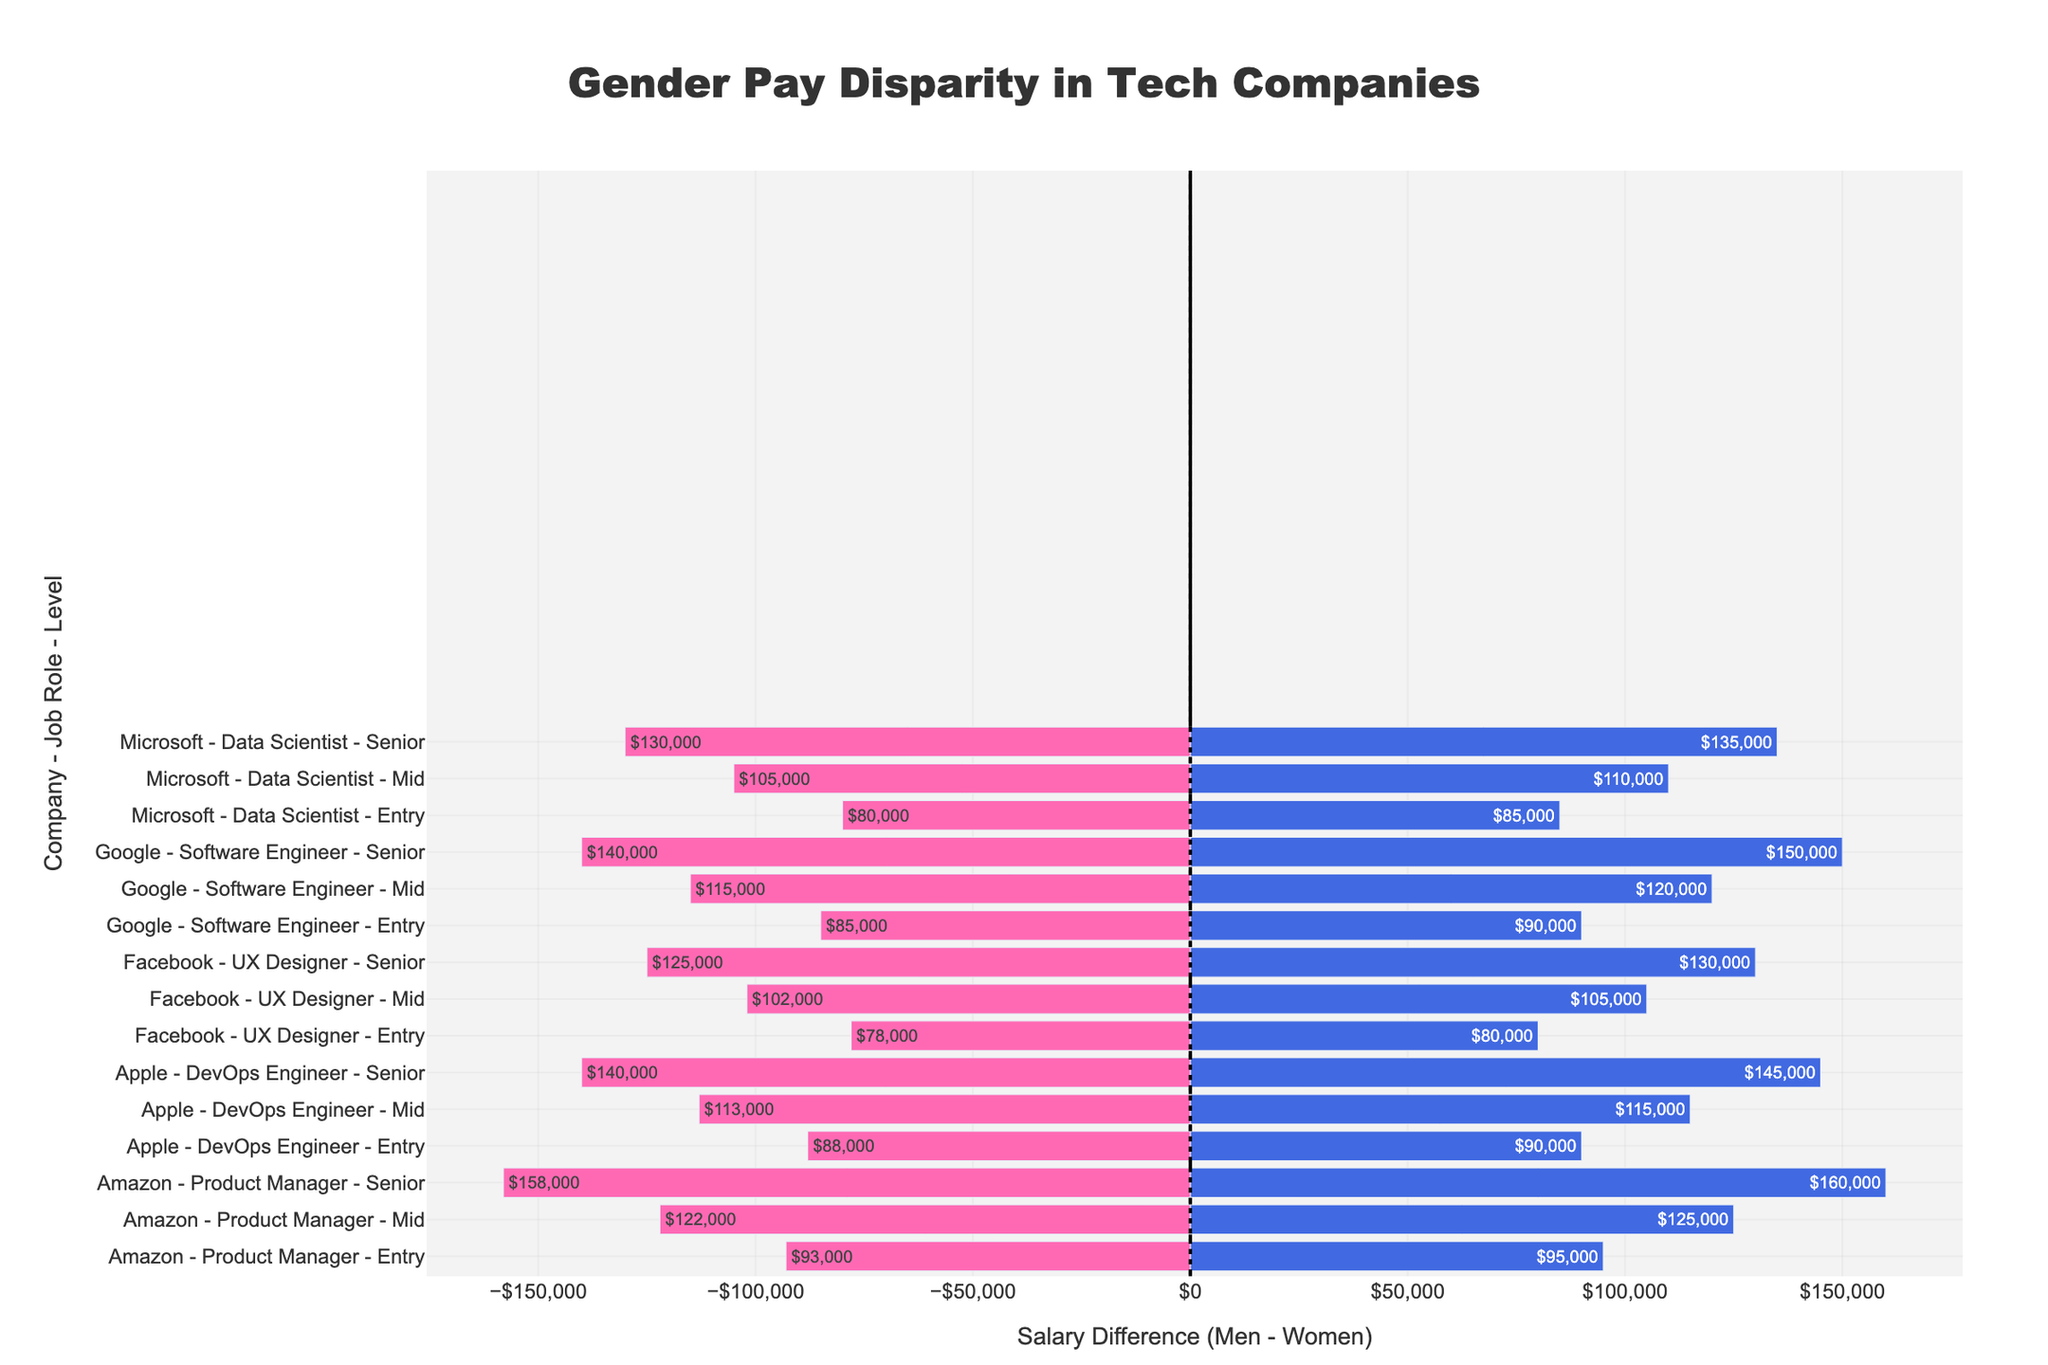How much more do mid-level male software engineers at Google earn compared to their female counterparts? To find the difference, we locate the salaries for mid-level male and female software engineers at Google. The male salary is $120,000 and the female salary is $115,000. The difference is $120,000 - $115,000.
Answer: $5,000 Which company has the smallest pay gap at the senior level for their evaluated job roles, and what is the gap? We compare the pay gap for senior-level roles at each company. The smallest gap is at Amazon, where the men earn $160,000 and women earn $158,000. The gap is $160,000 - $158,000.
Answer: Amazon, $2,000 Considering all companies, which entry-level role shows the largest pay gap and what is the amount? We check all entry-level roles for pay gaps: Google (Software Engineer: $90,000 vs. $85,000), Microsoft (Data Scientist: $85,000 vs. $80,000), Amazon (Product Manager: $95,000 vs. $93,000), Facebook (UX Designer: $80,000 vs. $78,000), and Apple (DevOps Engineer: $90,000 vs. $88,000). The largest gap is at Google with $90,000 - $85,000.
Answer: Google, $5,000 What is the average salary difference between men and women for senior roles across all companies? To get the average, sum the differences for senior roles: Google ($10,000), Microsoft ($5,000), Amazon ($2,000), Facebook ($5,000), Apple ($5,000). Then, average them: $(10,000 + 5,000 + 2,000 + 5,000 + 5,000) / 5$.
Answer: $5,400 In which job role at Microsoft is the pay gap largest and what is the gap? We review the pay gaps for each role at Microsoft: entry-level ($85,000 vs. $80,000), mid-level ($110,000 vs. $105,000), and senior ($135,000 vs. $130,000). The largest gap is at the entry level with $85,000 - $80,000.
Answer: Entry-level Data Scientist, $5,000 How does the pay gap at the entry level for Amazon's Product Managers compare visually to Google's entry-level software engineers? Look at the lengths of the bars representing these roles. Google's entry-level Software Engineer pay gap is visibly longer than Amazon's Product Manager, indicating a larger pay gap. By further inspecting, Google’s gap is $5,000 and Amazon's gap is $2,000.
Answer: Google's gap is larger Which color represents women’s salaries in the chart, and can you describe its location? We identify the colors used to represent different salaries: blue for men and pink for women. Bars with a visible negative extension in the chart represent women's salaries. These bars' colors are pink.
Answer: Pink, negative bars For mid-level roles, which company shows the highest salary difference, and what is the amount? Examine the pay gaps for mid-level roles: Google ($5,000), Microsoft ($5,000), Amazon ($3,000), Facebook ($3,000), Apple ($2,000). Google and Microsoft both show the highest pay difference of $5,000.
Answer: Google and Microsoft, $5,000 To which tech company does the lightest colored bar on the chart belong, and what does this bar represent? Visually inspecting for the lightest shade bar, which is the most positive (blue), we find it belongs to Google's senior-level Software Engineer, which represents the male salary of $150,000.
Answer: Google, senior-level Software Engineer 